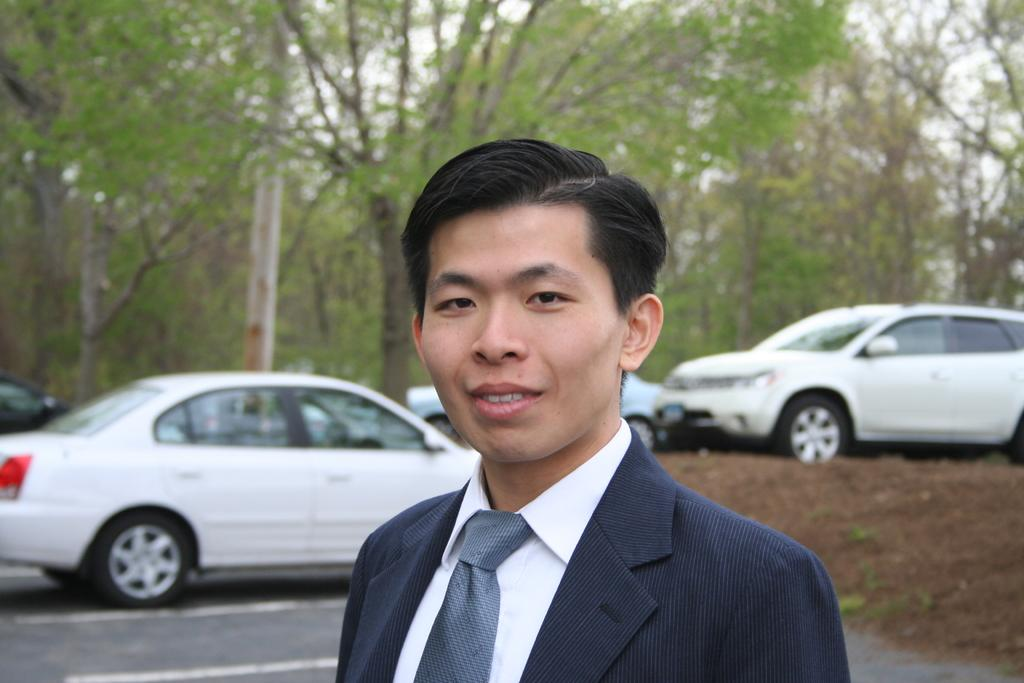What is the main subject of the image? There is a man in the image. What is the man wearing on his upper body? The man is wearing a black blazer and a white shirt. What accessory is the man wearing around his neck? The man is wearing a tie. What can be seen in the background of the image? There are cars and trees in the background of the image. What word is the man saying in the image? There is no indication of the man speaking or saying any words in the image. Is there a turkey present in the image? No, there is no turkey present in the image. 